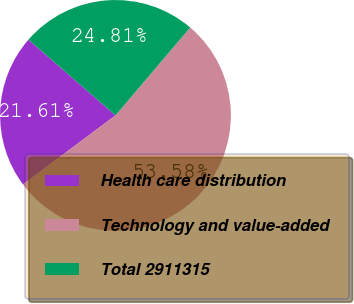Convert chart to OTSL. <chart><loc_0><loc_0><loc_500><loc_500><pie_chart><fcel>Health care distribution<fcel>Technology and value-added<fcel>Total 2911315<nl><fcel>21.61%<fcel>53.58%<fcel>24.81%<nl></chart> 